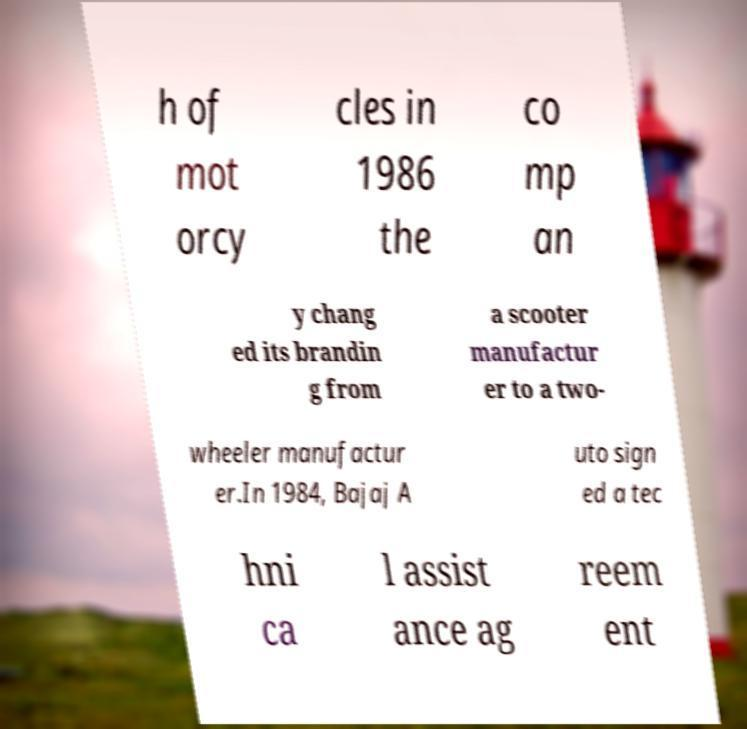Can you accurately transcribe the text from the provided image for me? h of mot orcy cles in 1986 the co mp an y chang ed its brandin g from a scooter manufactur er to a two- wheeler manufactur er.In 1984, Bajaj A uto sign ed a tec hni ca l assist ance ag reem ent 